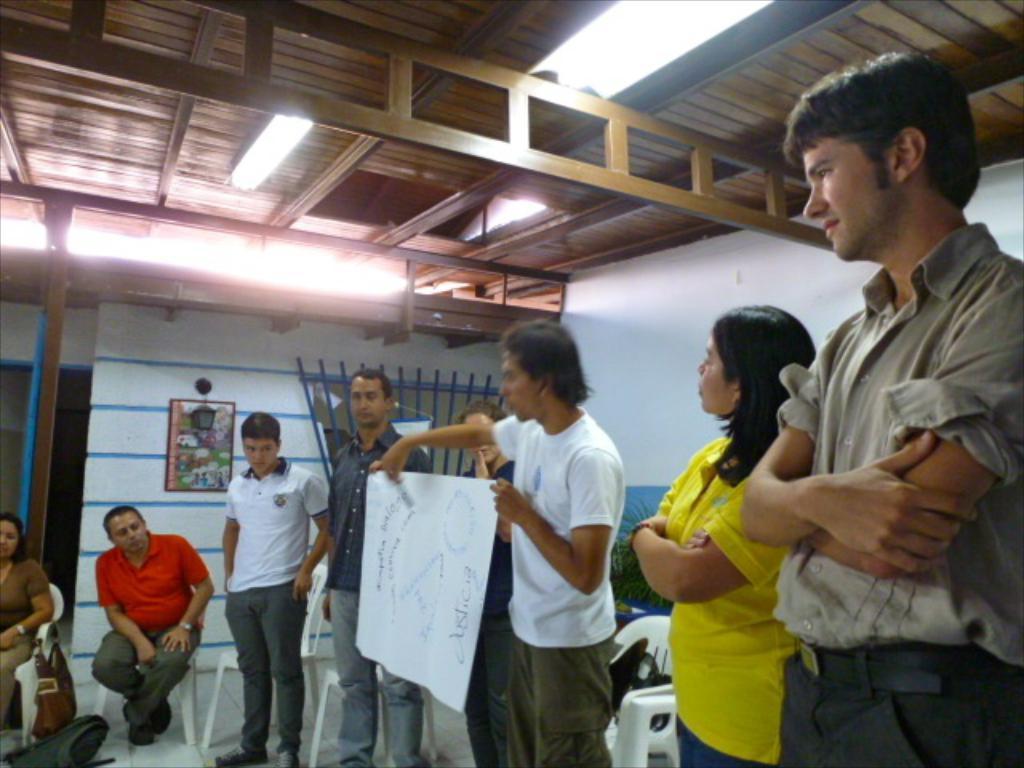Describe this image in one or two sentences. There is a man holding a chart and there are people sitting and standing in the foreground area of the image, there is a frame, it seems like a door in the background, there are lamps and a roof at the top side. 